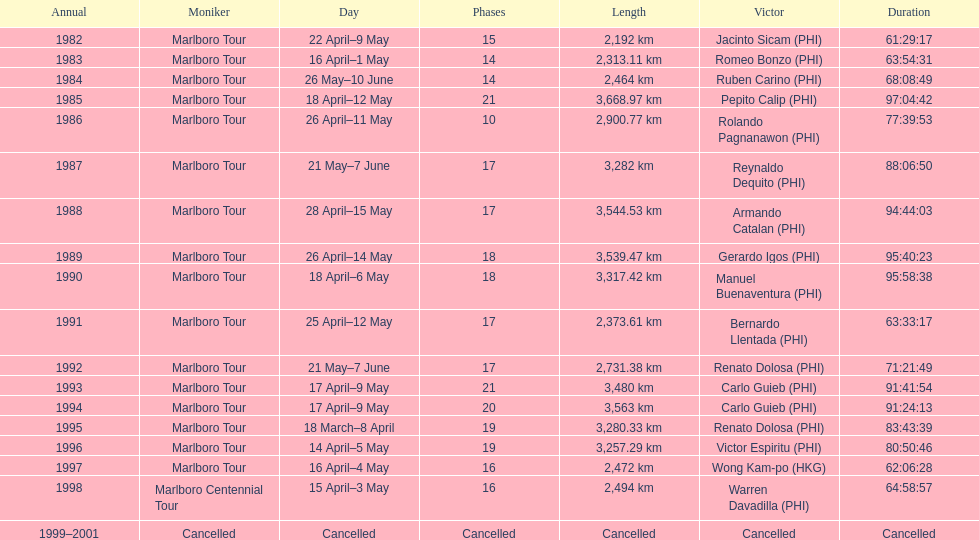Who is mentioned after romeo bonzo? Ruben Carino (PHI). 